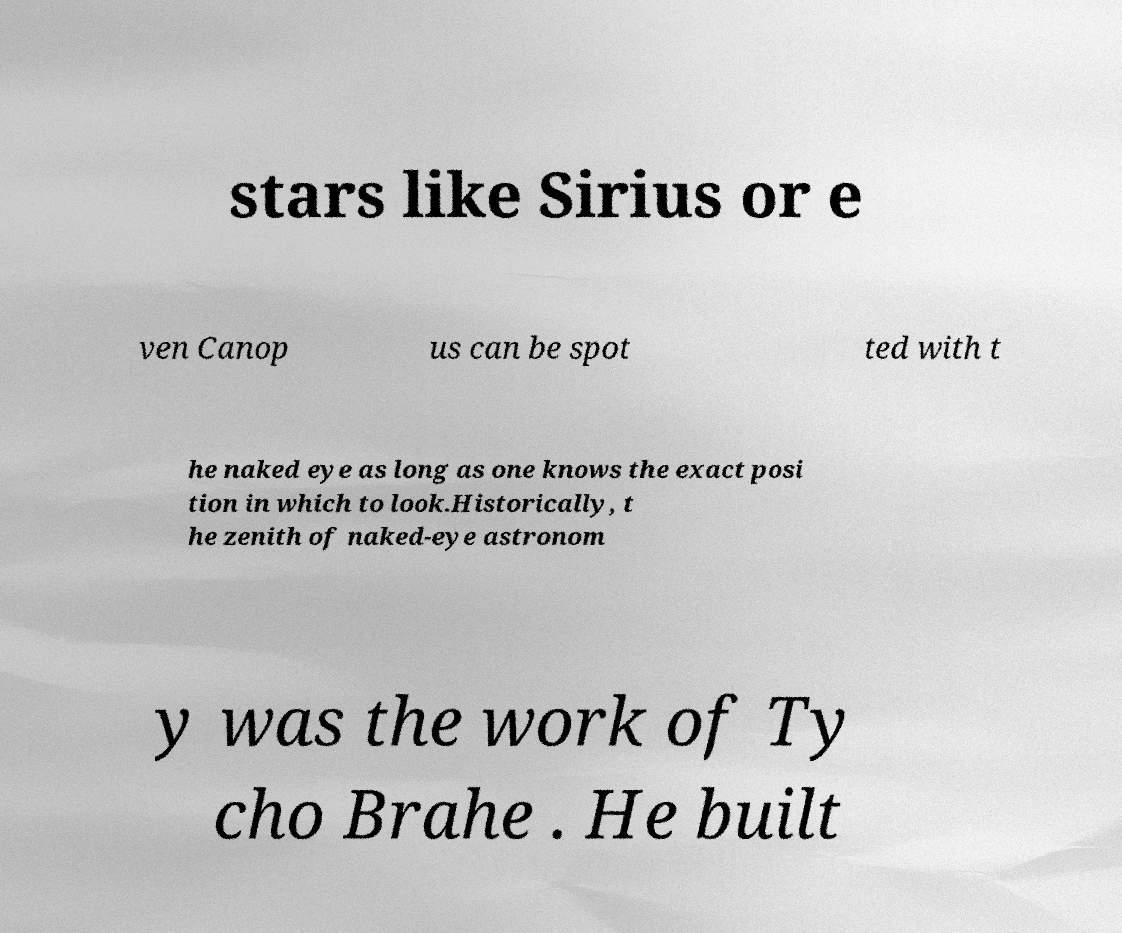Can you read and provide the text displayed in the image?This photo seems to have some interesting text. Can you extract and type it out for me? stars like Sirius or e ven Canop us can be spot ted with t he naked eye as long as one knows the exact posi tion in which to look.Historically, t he zenith of naked-eye astronom y was the work of Ty cho Brahe . He built 